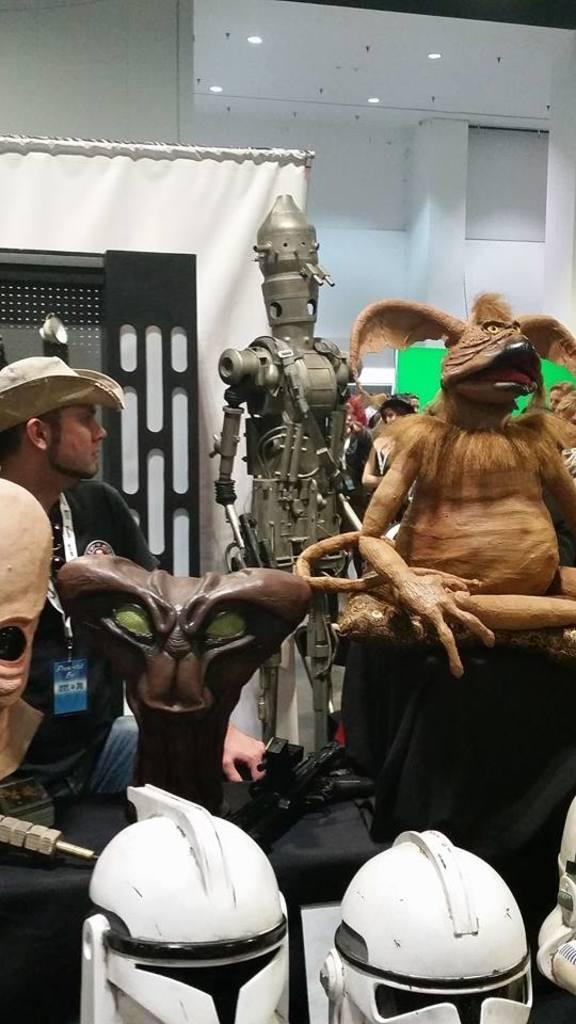How would you summarize this image in a sentence or two? In this image there is a man sitting. In front of him there is a table. On the table there are many sculptures. Behind him there is another sculpture. At the bottom there are helmets. In the background there is a wall. There are lights to the ceiling. 